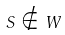<formula> <loc_0><loc_0><loc_500><loc_500>S \notin W</formula> 